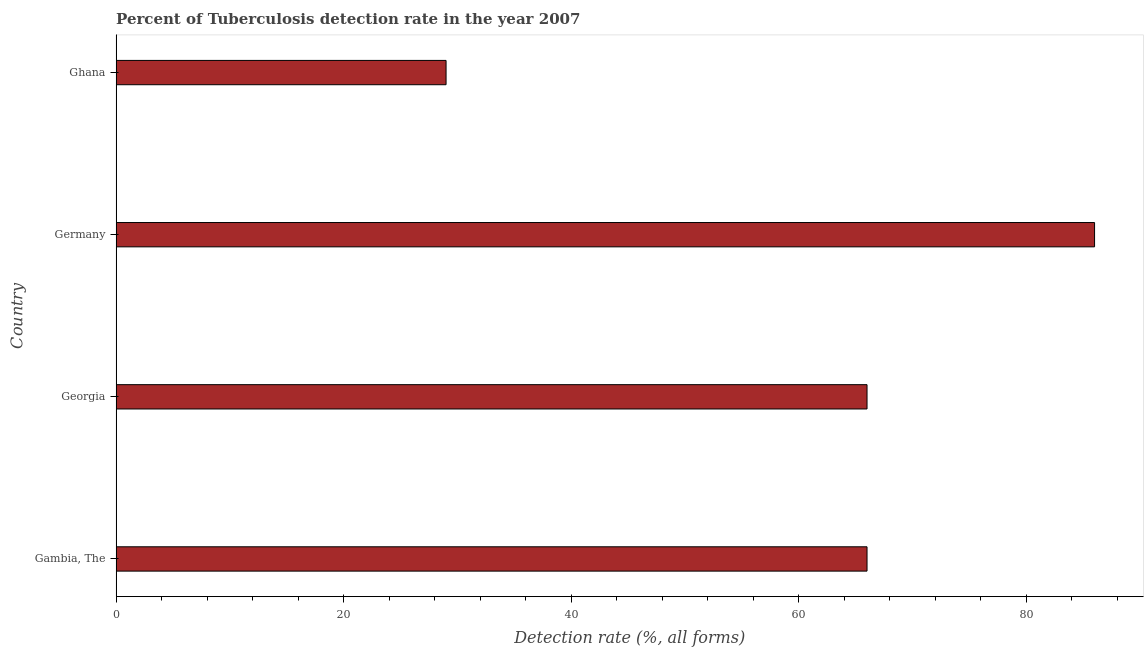What is the title of the graph?
Ensure brevity in your answer.  Percent of Tuberculosis detection rate in the year 2007. What is the label or title of the X-axis?
Your answer should be very brief. Detection rate (%, all forms). What is the label or title of the Y-axis?
Provide a short and direct response. Country. What is the detection rate of tuberculosis in Georgia?
Give a very brief answer. 66. In which country was the detection rate of tuberculosis maximum?
Provide a succinct answer. Germany. What is the sum of the detection rate of tuberculosis?
Offer a terse response. 247. In how many countries, is the detection rate of tuberculosis greater than 64 %?
Provide a succinct answer. 3. What is the ratio of the detection rate of tuberculosis in Gambia, The to that in Ghana?
Make the answer very short. 2.28. Is the detection rate of tuberculosis in Gambia, The less than that in Germany?
Offer a terse response. Yes. Is the difference between the detection rate of tuberculosis in Georgia and Germany greater than the difference between any two countries?
Your answer should be very brief. No. What is the difference between the highest and the lowest detection rate of tuberculosis?
Your answer should be very brief. 57. In how many countries, is the detection rate of tuberculosis greater than the average detection rate of tuberculosis taken over all countries?
Your response must be concise. 3. What is the difference between two consecutive major ticks on the X-axis?
Keep it short and to the point. 20. What is the Detection rate (%, all forms) of Gambia, The?
Ensure brevity in your answer.  66. What is the Detection rate (%, all forms) in Georgia?
Make the answer very short. 66. What is the Detection rate (%, all forms) in Germany?
Provide a succinct answer. 86. What is the difference between the Detection rate (%, all forms) in Gambia, The and Germany?
Your answer should be compact. -20. What is the difference between the Detection rate (%, all forms) in Gambia, The and Ghana?
Offer a very short reply. 37. What is the ratio of the Detection rate (%, all forms) in Gambia, The to that in Georgia?
Provide a succinct answer. 1. What is the ratio of the Detection rate (%, all forms) in Gambia, The to that in Germany?
Your response must be concise. 0.77. What is the ratio of the Detection rate (%, all forms) in Gambia, The to that in Ghana?
Provide a succinct answer. 2.28. What is the ratio of the Detection rate (%, all forms) in Georgia to that in Germany?
Offer a very short reply. 0.77. What is the ratio of the Detection rate (%, all forms) in Georgia to that in Ghana?
Offer a very short reply. 2.28. What is the ratio of the Detection rate (%, all forms) in Germany to that in Ghana?
Your answer should be compact. 2.97. 